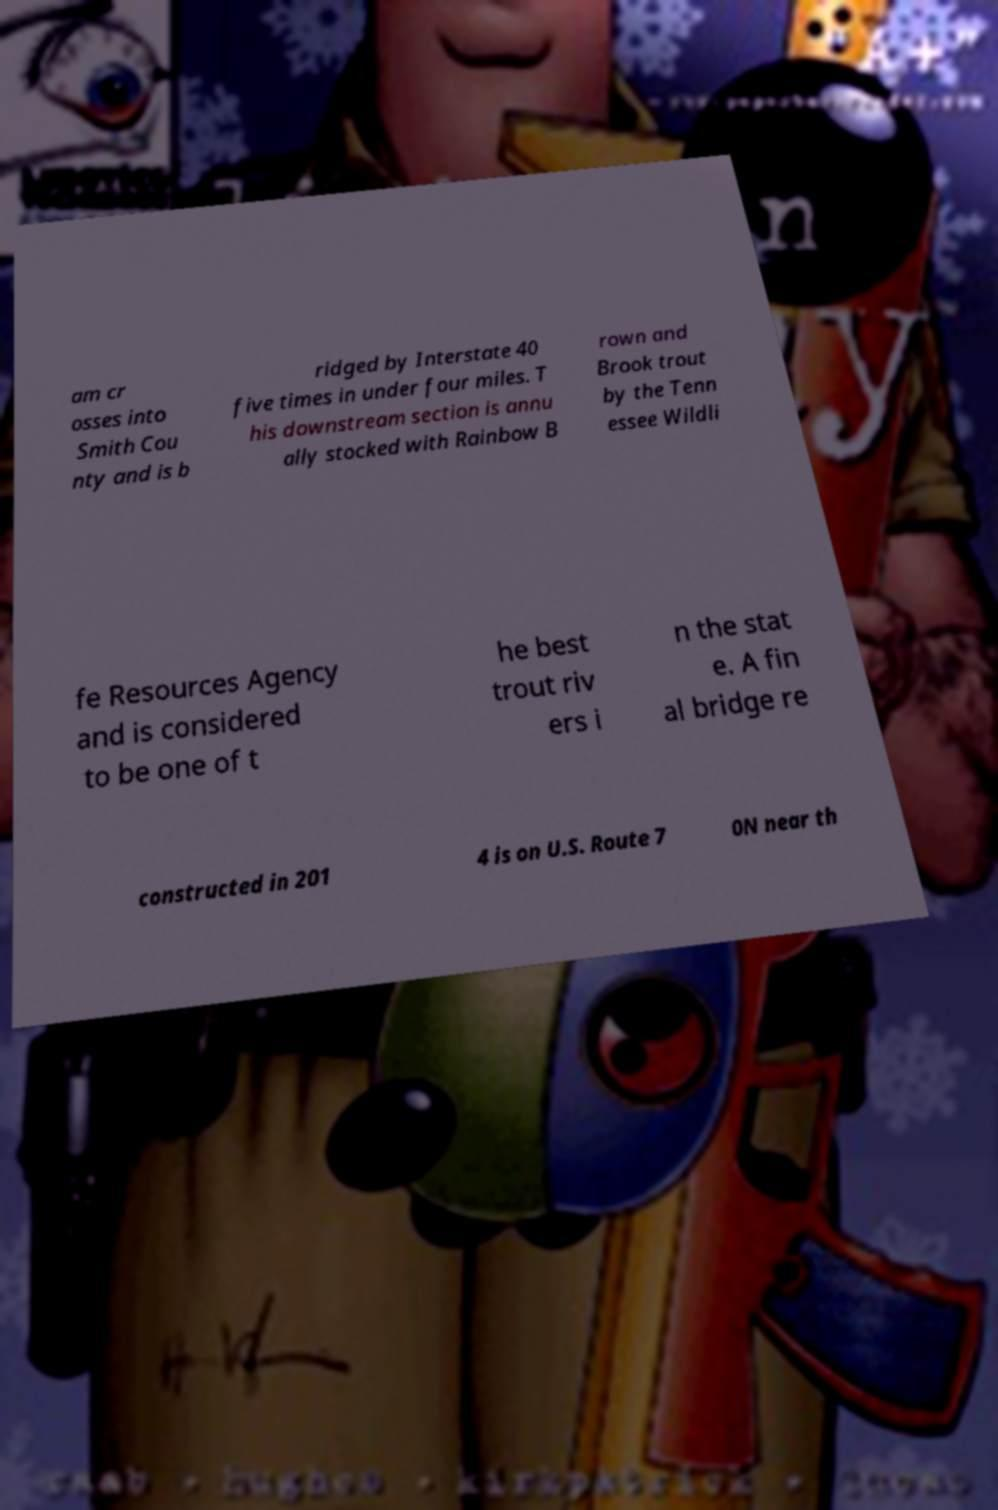What messages or text are displayed in this image? I need them in a readable, typed format. am cr osses into Smith Cou nty and is b ridged by Interstate 40 five times in under four miles. T his downstream section is annu ally stocked with Rainbow B rown and Brook trout by the Tenn essee Wildli fe Resources Agency and is considered to be one of t he best trout riv ers i n the stat e. A fin al bridge re constructed in 201 4 is on U.S. Route 7 0N near th 